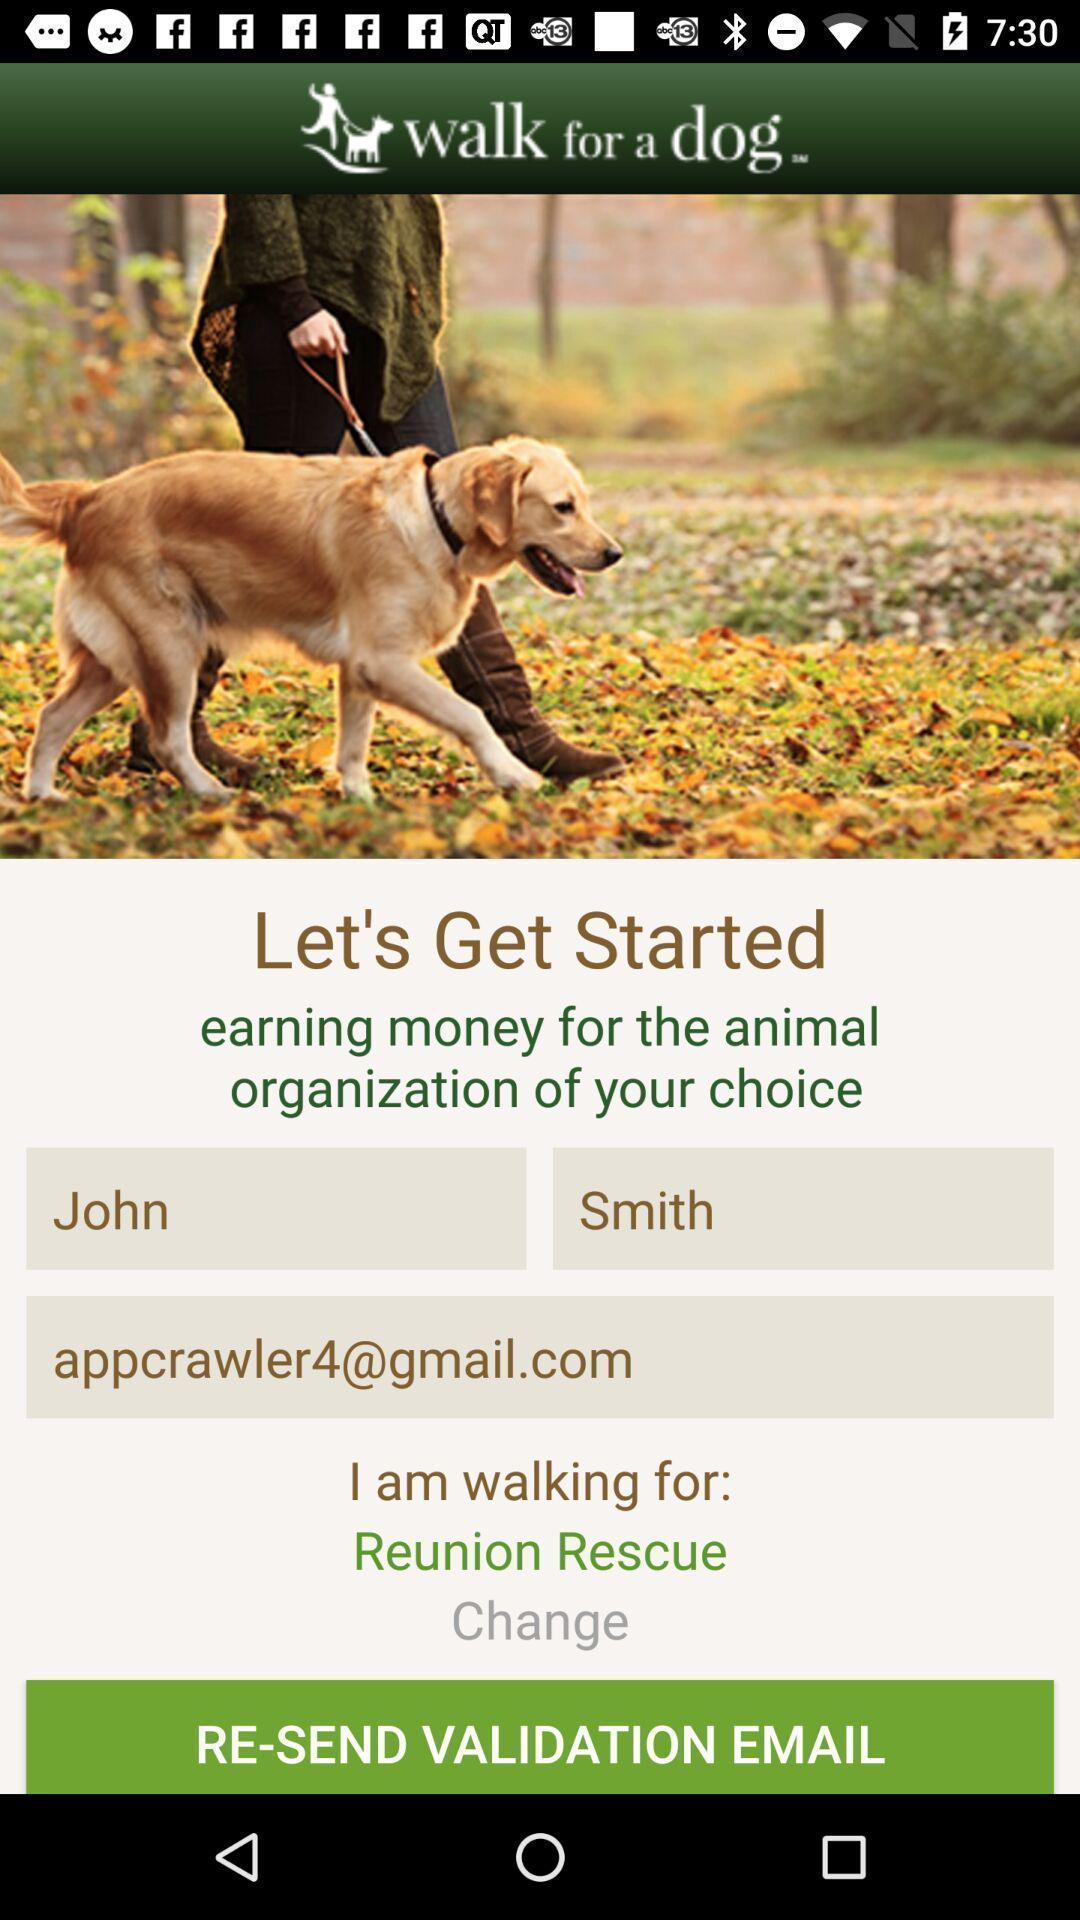Summarize the information in this screenshot. Welcome page. 